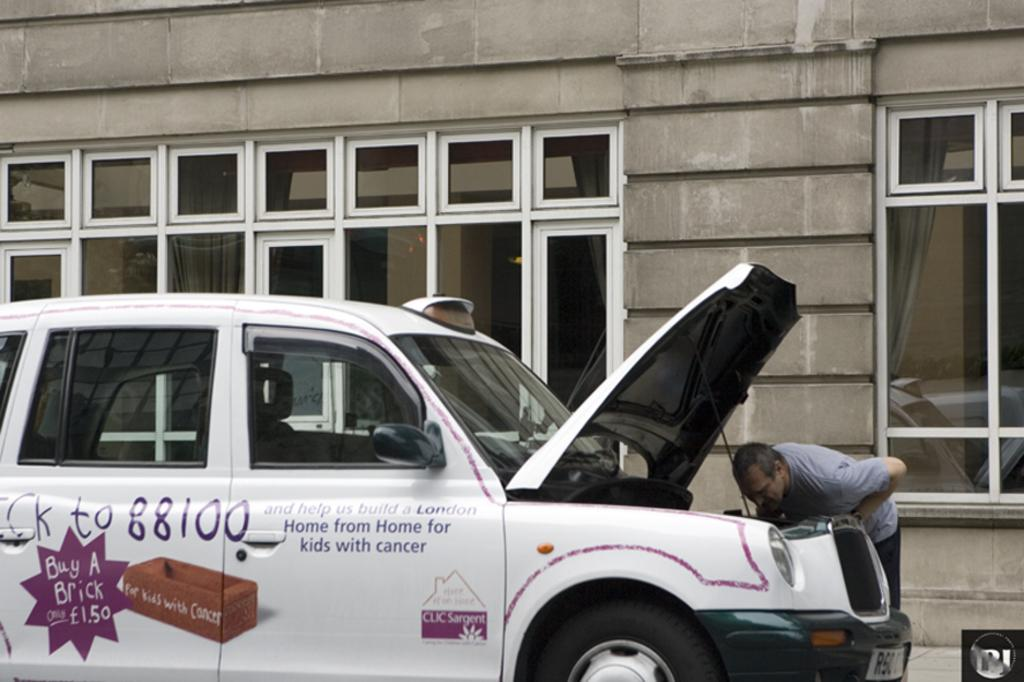<image>
Present a compact description of the photo's key features. a man inspecting the hood of his white truck for the company trying to build a london home for children with cancer 